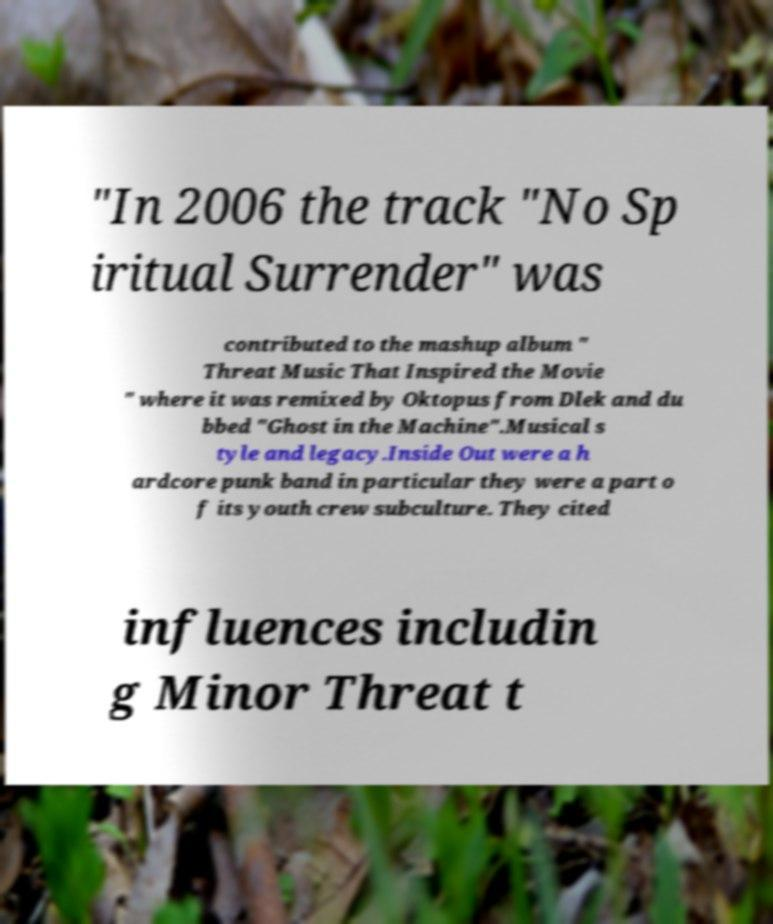I need the written content from this picture converted into text. Can you do that? "In 2006 the track "No Sp iritual Surrender" was contributed to the mashup album " Threat Music That Inspired the Movie " where it was remixed by Oktopus from Dlek and du bbed "Ghost in the Machine".Musical s tyle and legacy.Inside Out were a h ardcore punk band in particular they were a part o f its youth crew subculture. They cited influences includin g Minor Threat t 